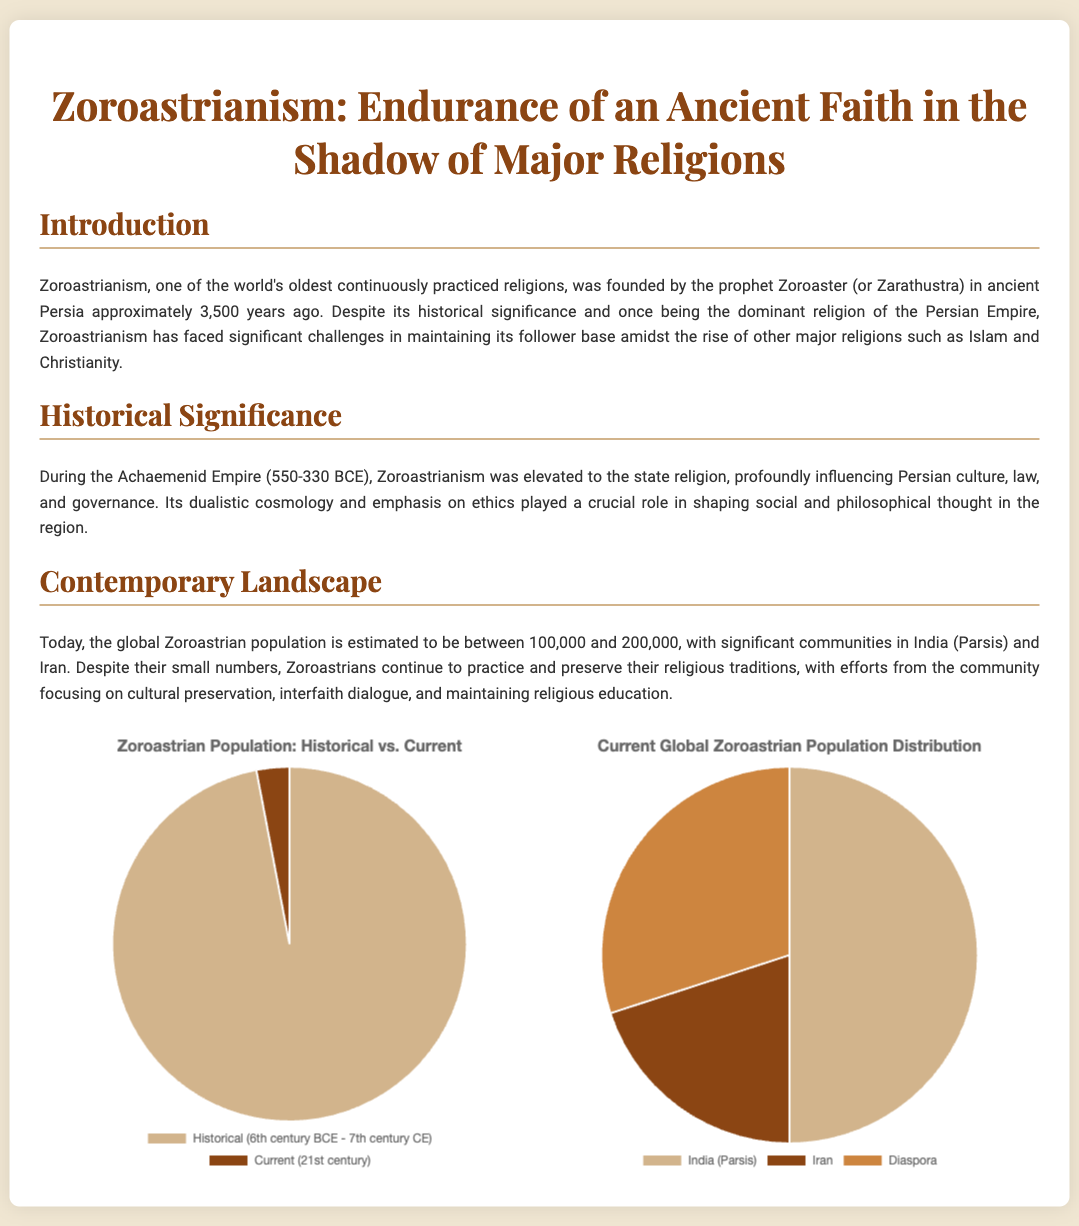What was the original state religion of the Achaemenid Empire? Zoroastrianism was elevated to the state religion during the Achaemenid Empire, influencing Persian culture and governance.
Answer: Zoroastrianism What is the estimated range of the current global Zoroastrian population? The document states the current Zoroastrian population is estimated to be between 100,000 and 200,000.
Answer: 100,000 to 200,000 During which centuries was Zoroastrianism considered a dominant religion? The historical pie chart indicates that Zoroastrianism was dominant during the period from the 6th century BCE to the 7th century CE.
Answer: 6th century BCE - 7th century CE What percentage of the current global Zoroastrian population is in India (Parsis)? The current population distribution chart shows that 50% of Zoroastrians are in India (Parsis).
Answer: 50% Which community is noted for its efforts in cultural preservation and interfaith dialogue? The document highlights that Zoroastrians continue to practice and preserve their traditions, focusing on cultural preservation and interfaith dialogue.
Answer: Zoroastrians What two colors are used to represent historical and current populations in the pie charts? The historical pie chart uses shades of brown, specifically #D2B48C and #8B4513, indicating the historical and current populations respectively.
Answer: Brown shades What is the title of the presentation slide? The title of the slide encapsulates the main theme of the document regarding Zoroastrianism.
Answer: Zoroastrianism: Endurance of an Ancient Faith in the Shadow of Major Religions What is represented by the segment labeled 'Diaspora' in the current population pie chart? The pie chart indicates that the 'Diaspora' group represents 30% of the global Zoroastrian population distribution.
Answer: 30% 